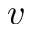Convert formula to latex. <formula><loc_0><loc_0><loc_500><loc_500>v</formula> 